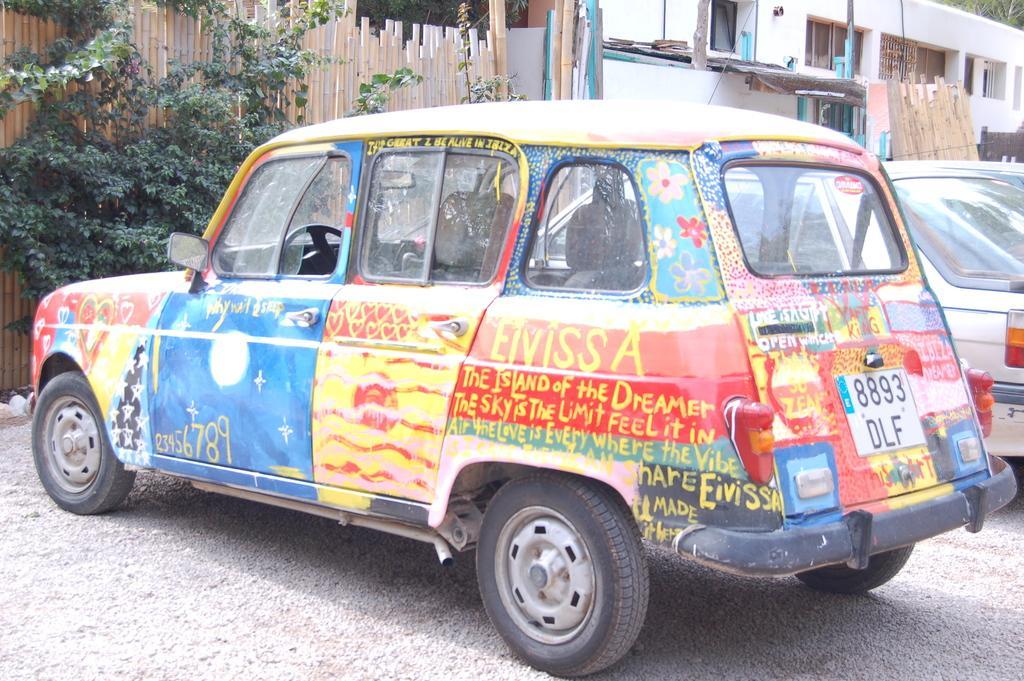Describe this image in one or two sentences. In this picture there is a vehicle which is painted in different colors and there is something written on it and there is another vehicle beside it and there are few plants and a fence in front of it and there is a house and some other objects in the right corner. 